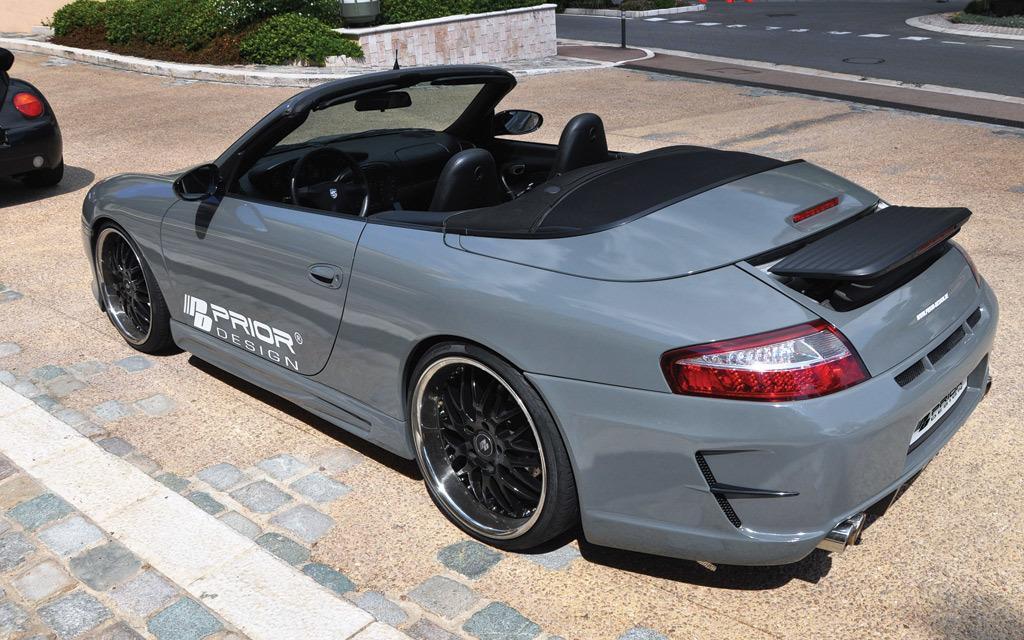Please provide a concise description of this image. In this picture we can see a car on the ground, and at side here is the road and paint on it, Here is the small shrubs, and here is the wall. 